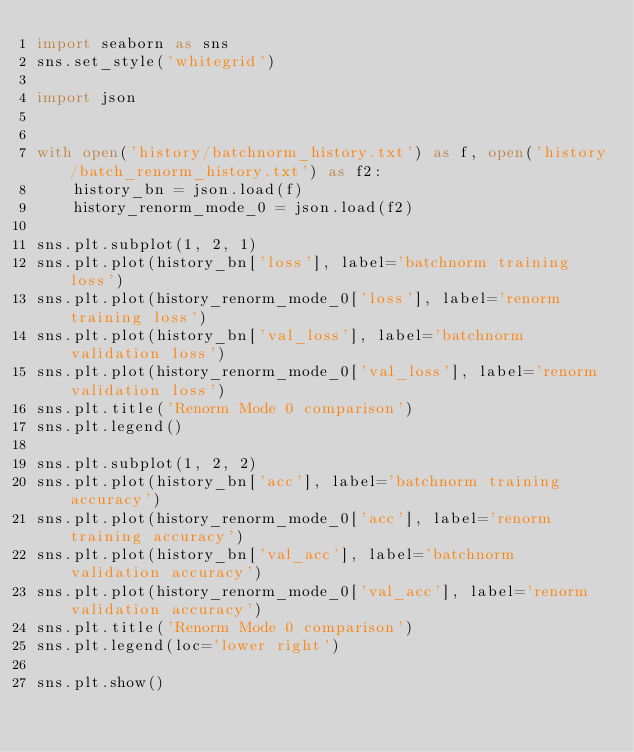Convert code to text. <code><loc_0><loc_0><loc_500><loc_500><_Python_>import seaborn as sns
sns.set_style('whitegrid')

import json


with open('history/batchnorm_history.txt') as f, open('history/batch_renorm_history.txt') as f2:
    history_bn = json.load(f)
    history_renorm_mode_0 = json.load(f2)

sns.plt.subplot(1, 2, 1)
sns.plt.plot(history_bn['loss'], label='batchnorm training loss')
sns.plt.plot(history_renorm_mode_0['loss'], label='renorm training loss')
sns.plt.plot(history_bn['val_loss'], label='batchnorm validation loss')
sns.plt.plot(history_renorm_mode_0['val_loss'], label='renorm validation loss')
sns.plt.title('Renorm Mode 0 comparison')
sns.plt.legend()

sns.plt.subplot(1, 2, 2)
sns.plt.plot(history_bn['acc'], label='batchnorm training accuracy')
sns.plt.plot(history_renorm_mode_0['acc'], label='renorm training accuracy')
sns.plt.plot(history_bn['val_acc'], label='batchnorm validation accuracy')
sns.plt.plot(history_renorm_mode_0['val_acc'], label='renorm validation accuracy')
sns.plt.title('Renorm Mode 0 comparison')
sns.plt.legend(loc='lower right')

sns.plt.show()</code> 